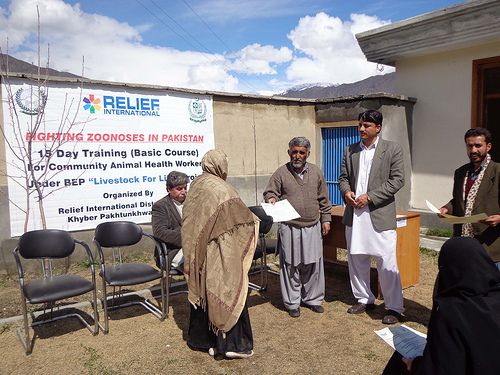<image>
Is there a desk behind the man? Yes. From this viewpoint, the desk is positioned behind the man, with the man partially or fully occluding the desk. 